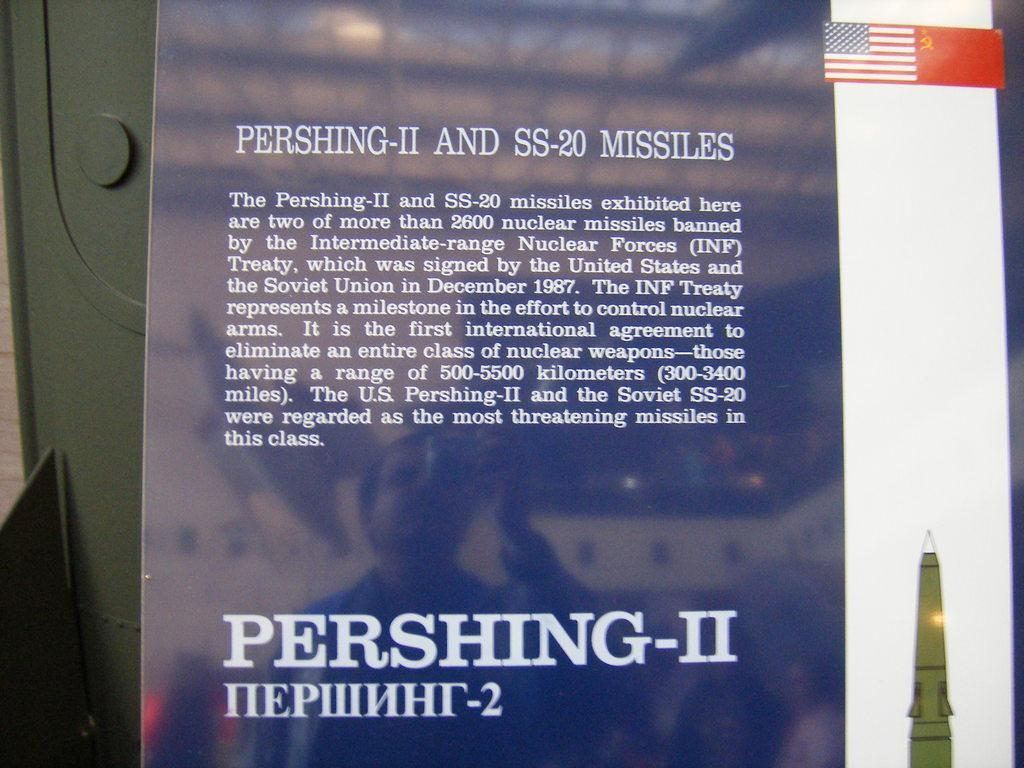<image>
Summarize the visual content of the image. A page describing the Pershing-II and SS-20 missiles. 